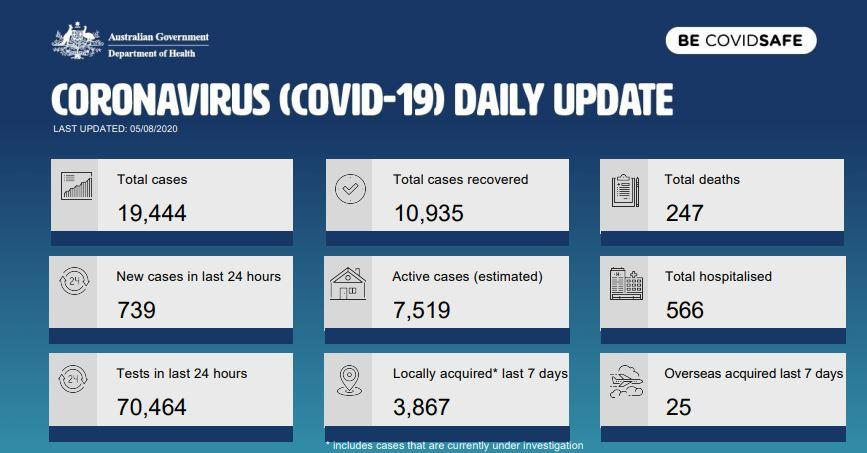Specify some key components in this picture. A total of 10,935 cases have been recovered. In the past 24 hours, there have been 70,464 tests conducted. In the past week, there were 25 cases of overseas acquisition reported. According to the data, a total of 566 individuals were hospitalized. As of May 8th, 2020, the total number of deaths was 247. 